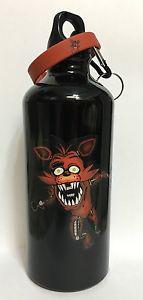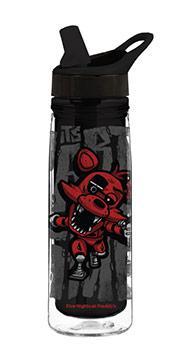The first image is the image on the left, the second image is the image on the right. Examine the images to the left and right. Is the description "Both images contain one mostly black reusable water bottle." accurate? Answer yes or no. Yes. 